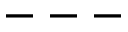Convert formula to latex. <formula><loc_0><loc_0><loc_500><loc_500>- - -</formula> 